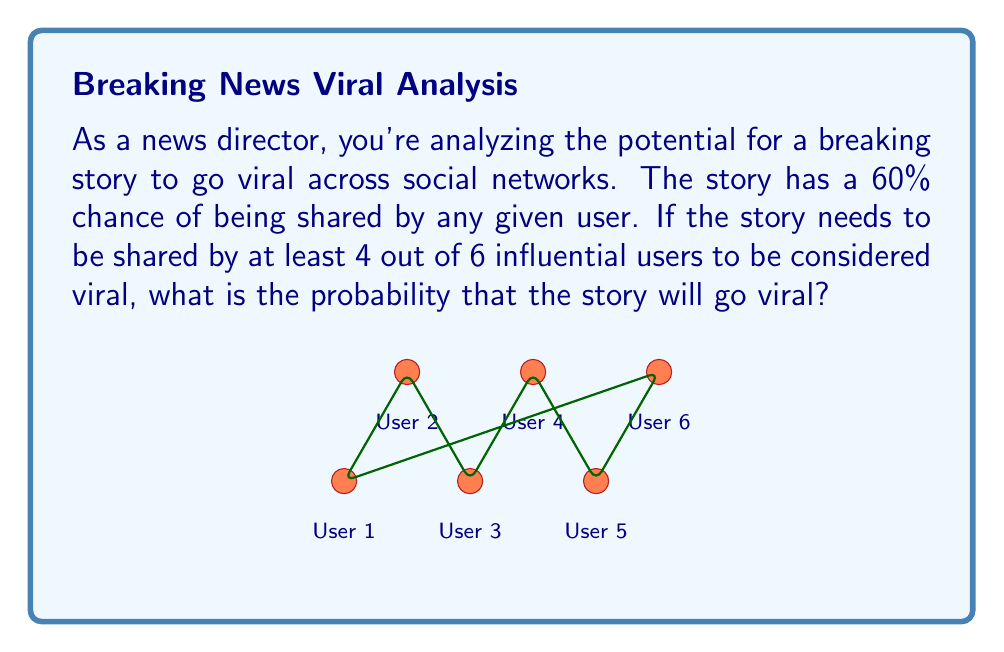Show me your answer to this math problem. Let's approach this step-by-step:

1) This is a binomial probability problem. We need to find the probability of at least 4 successes out of 6 trials, where each trial has a 60% chance of success.

2) The probability of exactly $k$ successes in $n$ trials is given by the binomial probability formula:

   $P(X = k) = \binom{n}{k} p^k (1-p)^{n-k}$

   where $n$ is the number of trials, $k$ is the number of successes, $p$ is the probability of success on each trial.

3) We need to calculate this for $k = 4$, $k = 5$, and $k = 6$, then sum these probabilities:

   $P(\text{viral}) = P(X = 4) + P(X = 5) + P(X = 6)$

4) Let's calculate each:

   For $k = 4$: 
   $P(X = 4) = \binom{6}{4} (0.6)^4 (0.4)^2 = 15 \times 0.1296 \times 0.16 = 0.3110$

   For $k = 5$:
   $P(X = 5) = \binom{6}{5} (0.6)^5 (0.4)^1 = 6 \times 0.07776 \times 0.4 = 0.1866$

   For $k = 6$:
   $P(X = 6) = \binom{6}{6} (0.6)^6 (0.4)^0 = 1 \times 0.046656 \times 1 = 0.0467$

5) Sum these probabilities:

   $P(\text{viral}) = 0.3110 + 0.1866 + 0.0467 = 0.5443$

Therefore, the probability that the story will go viral is approximately 0.5443 or 54.43%.
Answer: $0.5443$ or $54.43\%$ 